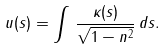Convert formula to latex. <formula><loc_0><loc_0><loc_500><loc_500>u ( s ) = \int \, \frac { \kappa ( s ) } { \sqrt { 1 - n ^ { 2 } } } \, d s .</formula> 